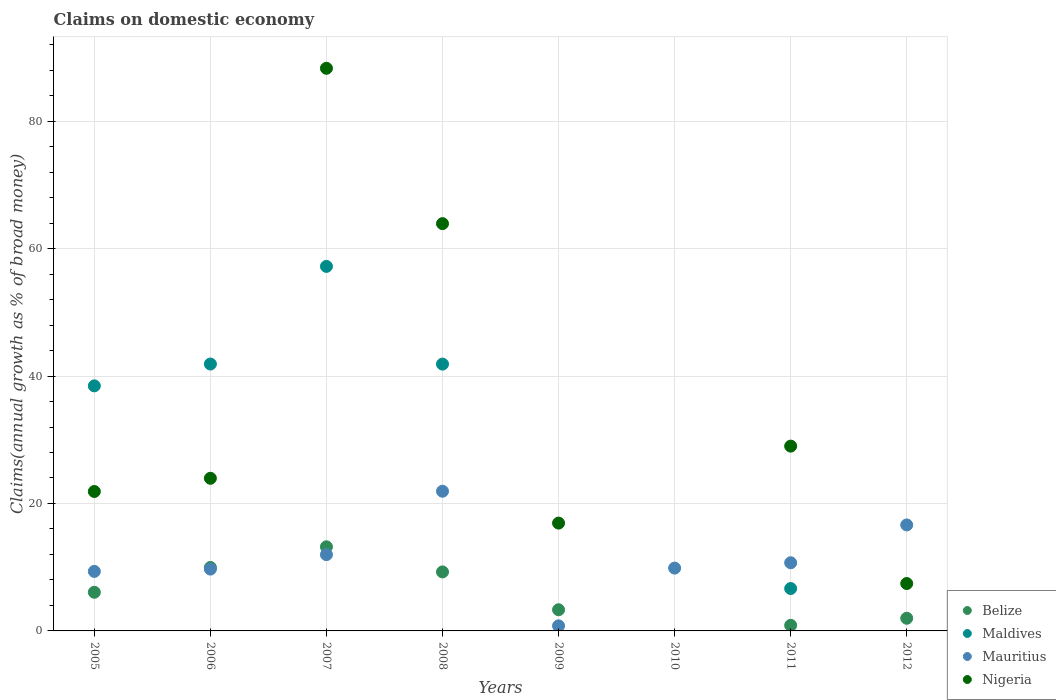How many different coloured dotlines are there?
Keep it short and to the point. 4. What is the percentage of broad money claimed on domestic economy in Nigeria in 2008?
Your answer should be compact. 63.92. Across all years, what is the maximum percentage of broad money claimed on domestic economy in Nigeria?
Make the answer very short. 88.3. Across all years, what is the minimum percentage of broad money claimed on domestic economy in Maldives?
Offer a terse response. 0. In which year was the percentage of broad money claimed on domestic economy in Mauritius maximum?
Provide a short and direct response. 2008. What is the total percentage of broad money claimed on domestic economy in Mauritius in the graph?
Ensure brevity in your answer.  90.93. What is the difference between the percentage of broad money claimed on domestic economy in Mauritius in 2005 and that in 2012?
Your answer should be very brief. -7.29. What is the difference between the percentage of broad money claimed on domestic economy in Nigeria in 2006 and the percentage of broad money claimed on domestic economy in Belize in 2005?
Provide a succinct answer. 17.89. What is the average percentage of broad money claimed on domestic economy in Belize per year?
Offer a very short reply. 5.58. In the year 2006, what is the difference between the percentage of broad money claimed on domestic economy in Mauritius and percentage of broad money claimed on domestic economy in Belize?
Give a very brief answer. -0.25. In how many years, is the percentage of broad money claimed on domestic economy in Nigeria greater than 44 %?
Make the answer very short. 2. What is the ratio of the percentage of broad money claimed on domestic economy in Mauritius in 2008 to that in 2011?
Provide a succinct answer. 2.05. Is the percentage of broad money claimed on domestic economy in Mauritius in 2009 less than that in 2011?
Offer a very short reply. Yes. Is the difference between the percentage of broad money claimed on domestic economy in Mauritius in 2008 and 2012 greater than the difference between the percentage of broad money claimed on domestic economy in Belize in 2008 and 2012?
Provide a succinct answer. No. What is the difference between the highest and the second highest percentage of broad money claimed on domestic economy in Belize?
Give a very brief answer. 3.24. What is the difference between the highest and the lowest percentage of broad money claimed on domestic economy in Maldives?
Your response must be concise. 57.21. Is it the case that in every year, the sum of the percentage of broad money claimed on domestic economy in Mauritius and percentage of broad money claimed on domestic economy in Belize  is greater than the sum of percentage of broad money claimed on domestic economy in Maldives and percentage of broad money claimed on domestic economy in Nigeria?
Offer a terse response. No. Does the percentage of broad money claimed on domestic economy in Nigeria monotonically increase over the years?
Offer a terse response. No. Is the percentage of broad money claimed on domestic economy in Mauritius strictly less than the percentage of broad money claimed on domestic economy in Nigeria over the years?
Make the answer very short. No. How many dotlines are there?
Ensure brevity in your answer.  4. How many years are there in the graph?
Ensure brevity in your answer.  8. What is the difference between two consecutive major ticks on the Y-axis?
Make the answer very short. 20. Does the graph contain any zero values?
Ensure brevity in your answer.  Yes. Does the graph contain grids?
Give a very brief answer. Yes. How many legend labels are there?
Offer a very short reply. 4. How are the legend labels stacked?
Your response must be concise. Vertical. What is the title of the graph?
Provide a short and direct response. Claims on domestic economy. What is the label or title of the X-axis?
Your answer should be compact. Years. What is the label or title of the Y-axis?
Offer a very short reply. Claims(annual growth as % of broad money). What is the Claims(annual growth as % of broad money) in Belize in 2005?
Your answer should be compact. 6.07. What is the Claims(annual growth as % of broad money) of Maldives in 2005?
Your answer should be very brief. 38.46. What is the Claims(annual growth as % of broad money) of Mauritius in 2005?
Keep it short and to the point. 9.34. What is the Claims(annual growth as % of broad money) in Nigeria in 2005?
Provide a short and direct response. 21.88. What is the Claims(annual growth as % of broad money) in Belize in 2006?
Offer a terse response. 9.96. What is the Claims(annual growth as % of broad money) of Maldives in 2006?
Offer a terse response. 41.89. What is the Claims(annual growth as % of broad money) of Mauritius in 2006?
Provide a short and direct response. 9.7. What is the Claims(annual growth as % of broad money) of Nigeria in 2006?
Make the answer very short. 23.95. What is the Claims(annual growth as % of broad money) of Belize in 2007?
Your answer should be compact. 13.2. What is the Claims(annual growth as % of broad money) of Maldives in 2007?
Your answer should be compact. 57.21. What is the Claims(annual growth as % of broad money) in Mauritius in 2007?
Your response must be concise. 11.97. What is the Claims(annual growth as % of broad money) in Nigeria in 2007?
Keep it short and to the point. 88.3. What is the Claims(annual growth as % of broad money) of Belize in 2008?
Your answer should be very brief. 9.26. What is the Claims(annual growth as % of broad money) of Maldives in 2008?
Your answer should be very brief. 41.87. What is the Claims(annual growth as % of broad money) in Mauritius in 2008?
Your answer should be compact. 21.92. What is the Claims(annual growth as % of broad money) in Nigeria in 2008?
Your response must be concise. 63.92. What is the Claims(annual growth as % of broad money) of Belize in 2009?
Offer a very short reply. 3.32. What is the Claims(annual growth as % of broad money) of Maldives in 2009?
Your answer should be very brief. 0. What is the Claims(annual growth as % of broad money) of Mauritius in 2009?
Offer a very short reply. 0.8. What is the Claims(annual growth as % of broad money) in Nigeria in 2009?
Offer a terse response. 16.92. What is the Claims(annual growth as % of broad money) of Maldives in 2010?
Offer a terse response. 0. What is the Claims(annual growth as % of broad money) in Mauritius in 2010?
Offer a terse response. 9.86. What is the Claims(annual growth as % of broad money) of Belize in 2011?
Your answer should be very brief. 0.88. What is the Claims(annual growth as % of broad money) of Maldives in 2011?
Keep it short and to the point. 6.65. What is the Claims(annual growth as % of broad money) of Mauritius in 2011?
Your answer should be compact. 10.7. What is the Claims(annual growth as % of broad money) of Nigeria in 2011?
Provide a succinct answer. 29. What is the Claims(annual growth as % of broad money) of Belize in 2012?
Offer a very short reply. 1.99. What is the Claims(annual growth as % of broad money) in Maldives in 2012?
Provide a succinct answer. 0. What is the Claims(annual growth as % of broad money) of Mauritius in 2012?
Keep it short and to the point. 16.63. What is the Claims(annual growth as % of broad money) in Nigeria in 2012?
Your answer should be very brief. 7.44. Across all years, what is the maximum Claims(annual growth as % of broad money) in Belize?
Your answer should be compact. 13.2. Across all years, what is the maximum Claims(annual growth as % of broad money) in Maldives?
Make the answer very short. 57.21. Across all years, what is the maximum Claims(annual growth as % of broad money) of Mauritius?
Ensure brevity in your answer.  21.92. Across all years, what is the maximum Claims(annual growth as % of broad money) in Nigeria?
Your response must be concise. 88.3. Across all years, what is the minimum Claims(annual growth as % of broad money) of Belize?
Offer a very short reply. 0. Across all years, what is the minimum Claims(annual growth as % of broad money) in Maldives?
Give a very brief answer. 0. Across all years, what is the minimum Claims(annual growth as % of broad money) in Mauritius?
Ensure brevity in your answer.  0.8. Across all years, what is the minimum Claims(annual growth as % of broad money) in Nigeria?
Provide a short and direct response. 0. What is the total Claims(annual growth as % of broad money) of Belize in the graph?
Your response must be concise. 44.68. What is the total Claims(annual growth as % of broad money) of Maldives in the graph?
Provide a short and direct response. 186.08. What is the total Claims(annual growth as % of broad money) in Mauritius in the graph?
Your answer should be very brief. 90.93. What is the total Claims(annual growth as % of broad money) of Nigeria in the graph?
Your answer should be very brief. 251.41. What is the difference between the Claims(annual growth as % of broad money) of Belize in 2005 and that in 2006?
Provide a succinct answer. -3.89. What is the difference between the Claims(annual growth as % of broad money) in Maldives in 2005 and that in 2006?
Ensure brevity in your answer.  -3.43. What is the difference between the Claims(annual growth as % of broad money) in Mauritius in 2005 and that in 2006?
Keep it short and to the point. -0.36. What is the difference between the Claims(annual growth as % of broad money) of Nigeria in 2005 and that in 2006?
Ensure brevity in your answer.  -2.07. What is the difference between the Claims(annual growth as % of broad money) of Belize in 2005 and that in 2007?
Provide a short and direct response. -7.14. What is the difference between the Claims(annual growth as % of broad money) in Maldives in 2005 and that in 2007?
Provide a short and direct response. -18.75. What is the difference between the Claims(annual growth as % of broad money) of Mauritius in 2005 and that in 2007?
Your answer should be compact. -2.63. What is the difference between the Claims(annual growth as % of broad money) in Nigeria in 2005 and that in 2007?
Your answer should be compact. -66.42. What is the difference between the Claims(annual growth as % of broad money) of Belize in 2005 and that in 2008?
Keep it short and to the point. -3.19. What is the difference between the Claims(annual growth as % of broad money) of Maldives in 2005 and that in 2008?
Offer a very short reply. -3.41. What is the difference between the Claims(annual growth as % of broad money) of Mauritius in 2005 and that in 2008?
Offer a very short reply. -12.58. What is the difference between the Claims(annual growth as % of broad money) in Nigeria in 2005 and that in 2008?
Provide a short and direct response. -42.04. What is the difference between the Claims(annual growth as % of broad money) of Belize in 2005 and that in 2009?
Provide a short and direct response. 2.74. What is the difference between the Claims(annual growth as % of broad money) in Mauritius in 2005 and that in 2009?
Give a very brief answer. 8.54. What is the difference between the Claims(annual growth as % of broad money) of Nigeria in 2005 and that in 2009?
Your response must be concise. 4.96. What is the difference between the Claims(annual growth as % of broad money) of Mauritius in 2005 and that in 2010?
Your answer should be very brief. -0.52. What is the difference between the Claims(annual growth as % of broad money) in Belize in 2005 and that in 2011?
Offer a very short reply. 5.19. What is the difference between the Claims(annual growth as % of broad money) in Maldives in 2005 and that in 2011?
Provide a short and direct response. 31.81. What is the difference between the Claims(annual growth as % of broad money) of Mauritius in 2005 and that in 2011?
Offer a terse response. -1.36. What is the difference between the Claims(annual growth as % of broad money) of Nigeria in 2005 and that in 2011?
Your answer should be compact. -7.12. What is the difference between the Claims(annual growth as % of broad money) in Belize in 2005 and that in 2012?
Make the answer very short. 4.08. What is the difference between the Claims(annual growth as % of broad money) in Mauritius in 2005 and that in 2012?
Offer a terse response. -7.29. What is the difference between the Claims(annual growth as % of broad money) in Nigeria in 2005 and that in 2012?
Offer a terse response. 14.44. What is the difference between the Claims(annual growth as % of broad money) in Belize in 2006 and that in 2007?
Offer a terse response. -3.24. What is the difference between the Claims(annual growth as % of broad money) of Maldives in 2006 and that in 2007?
Offer a very short reply. -15.32. What is the difference between the Claims(annual growth as % of broad money) in Mauritius in 2006 and that in 2007?
Provide a succinct answer. -2.27. What is the difference between the Claims(annual growth as % of broad money) of Nigeria in 2006 and that in 2007?
Your response must be concise. -64.34. What is the difference between the Claims(annual growth as % of broad money) of Belize in 2006 and that in 2008?
Provide a succinct answer. 0.7. What is the difference between the Claims(annual growth as % of broad money) of Maldives in 2006 and that in 2008?
Make the answer very short. 0.01. What is the difference between the Claims(annual growth as % of broad money) in Mauritius in 2006 and that in 2008?
Offer a very short reply. -12.22. What is the difference between the Claims(annual growth as % of broad money) in Nigeria in 2006 and that in 2008?
Your answer should be very brief. -39.96. What is the difference between the Claims(annual growth as % of broad money) in Belize in 2006 and that in 2009?
Provide a succinct answer. 6.64. What is the difference between the Claims(annual growth as % of broad money) of Mauritius in 2006 and that in 2009?
Offer a very short reply. 8.91. What is the difference between the Claims(annual growth as % of broad money) in Nigeria in 2006 and that in 2009?
Ensure brevity in your answer.  7.03. What is the difference between the Claims(annual growth as % of broad money) in Mauritius in 2006 and that in 2010?
Provide a short and direct response. -0.16. What is the difference between the Claims(annual growth as % of broad money) of Belize in 2006 and that in 2011?
Provide a short and direct response. 9.08. What is the difference between the Claims(annual growth as % of broad money) in Maldives in 2006 and that in 2011?
Give a very brief answer. 35.23. What is the difference between the Claims(annual growth as % of broad money) in Mauritius in 2006 and that in 2011?
Your answer should be compact. -0.99. What is the difference between the Claims(annual growth as % of broad money) of Nigeria in 2006 and that in 2011?
Make the answer very short. -5.05. What is the difference between the Claims(annual growth as % of broad money) in Belize in 2006 and that in 2012?
Keep it short and to the point. 7.97. What is the difference between the Claims(annual growth as % of broad money) of Mauritius in 2006 and that in 2012?
Your answer should be compact. -6.93. What is the difference between the Claims(annual growth as % of broad money) in Nigeria in 2006 and that in 2012?
Offer a very short reply. 16.52. What is the difference between the Claims(annual growth as % of broad money) in Belize in 2007 and that in 2008?
Offer a terse response. 3.94. What is the difference between the Claims(annual growth as % of broad money) in Maldives in 2007 and that in 2008?
Offer a very short reply. 15.33. What is the difference between the Claims(annual growth as % of broad money) of Mauritius in 2007 and that in 2008?
Offer a very short reply. -9.95. What is the difference between the Claims(annual growth as % of broad money) of Nigeria in 2007 and that in 2008?
Provide a succinct answer. 24.38. What is the difference between the Claims(annual growth as % of broad money) of Belize in 2007 and that in 2009?
Your answer should be compact. 9.88. What is the difference between the Claims(annual growth as % of broad money) in Mauritius in 2007 and that in 2009?
Keep it short and to the point. 11.17. What is the difference between the Claims(annual growth as % of broad money) in Nigeria in 2007 and that in 2009?
Keep it short and to the point. 71.38. What is the difference between the Claims(annual growth as % of broad money) in Mauritius in 2007 and that in 2010?
Your answer should be compact. 2.11. What is the difference between the Claims(annual growth as % of broad money) in Belize in 2007 and that in 2011?
Provide a succinct answer. 12.32. What is the difference between the Claims(annual growth as % of broad money) in Maldives in 2007 and that in 2011?
Provide a short and direct response. 50.55. What is the difference between the Claims(annual growth as % of broad money) of Mauritius in 2007 and that in 2011?
Ensure brevity in your answer.  1.27. What is the difference between the Claims(annual growth as % of broad money) of Nigeria in 2007 and that in 2011?
Offer a terse response. 59.3. What is the difference between the Claims(annual growth as % of broad money) of Belize in 2007 and that in 2012?
Ensure brevity in your answer.  11.21. What is the difference between the Claims(annual growth as % of broad money) of Mauritius in 2007 and that in 2012?
Make the answer very short. -4.66. What is the difference between the Claims(annual growth as % of broad money) in Nigeria in 2007 and that in 2012?
Make the answer very short. 80.86. What is the difference between the Claims(annual growth as % of broad money) of Belize in 2008 and that in 2009?
Give a very brief answer. 5.94. What is the difference between the Claims(annual growth as % of broad money) of Mauritius in 2008 and that in 2009?
Your response must be concise. 21.12. What is the difference between the Claims(annual growth as % of broad money) of Nigeria in 2008 and that in 2009?
Give a very brief answer. 47. What is the difference between the Claims(annual growth as % of broad money) of Mauritius in 2008 and that in 2010?
Offer a very short reply. 12.06. What is the difference between the Claims(annual growth as % of broad money) of Belize in 2008 and that in 2011?
Make the answer very short. 8.38. What is the difference between the Claims(annual growth as % of broad money) of Maldives in 2008 and that in 2011?
Offer a terse response. 35.22. What is the difference between the Claims(annual growth as % of broad money) in Mauritius in 2008 and that in 2011?
Your answer should be very brief. 11.23. What is the difference between the Claims(annual growth as % of broad money) in Nigeria in 2008 and that in 2011?
Ensure brevity in your answer.  34.92. What is the difference between the Claims(annual growth as % of broad money) of Belize in 2008 and that in 2012?
Offer a terse response. 7.27. What is the difference between the Claims(annual growth as % of broad money) of Mauritius in 2008 and that in 2012?
Offer a terse response. 5.29. What is the difference between the Claims(annual growth as % of broad money) of Nigeria in 2008 and that in 2012?
Offer a terse response. 56.48. What is the difference between the Claims(annual growth as % of broad money) of Mauritius in 2009 and that in 2010?
Make the answer very short. -9.06. What is the difference between the Claims(annual growth as % of broad money) of Belize in 2009 and that in 2011?
Offer a very short reply. 2.44. What is the difference between the Claims(annual growth as % of broad money) in Mauritius in 2009 and that in 2011?
Your answer should be compact. -9.9. What is the difference between the Claims(annual growth as % of broad money) in Nigeria in 2009 and that in 2011?
Keep it short and to the point. -12.08. What is the difference between the Claims(annual growth as % of broad money) of Belize in 2009 and that in 2012?
Give a very brief answer. 1.33. What is the difference between the Claims(annual growth as % of broad money) of Mauritius in 2009 and that in 2012?
Your answer should be compact. -15.83. What is the difference between the Claims(annual growth as % of broad money) in Nigeria in 2009 and that in 2012?
Ensure brevity in your answer.  9.48. What is the difference between the Claims(annual growth as % of broad money) in Mauritius in 2010 and that in 2011?
Ensure brevity in your answer.  -0.84. What is the difference between the Claims(annual growth as % of broad money) in Mauritius in 2010 and that in 2012?
Provide a short and direct response. -6.77. What is the difference between the Claims(annual growth as % of broad money) in Belize in 2011 and that in 2012?
Your response must be concise. -1.11. What is the difference between the Claims(annual growth as % of broad money) of Mauritius in 2011 and that in 2012?
Ensure brevity in your answer.  -5.93. What is the difference between the Claims(annual growth as % of broad money) of Nigeria in 2011 and that in 2012?
Make the answer very short. 21.57. What is the difference between the Claims(annual growth as % of broad money) in Belize in 2005 and the Claims(annual growth as % of broad money) in Maldives in 2006?
Offer a very short reply. -35.82. What is the difference between the Claims(annual growth as % of broad money) in Belize in 2005 and the Claims(annual growth as % of broad money) in Mauritius in 2006?
Keep it short and to the point. -3.64. What is the difference between the Claims(annual growth as % of broad money) of Belize in 2005 and the Claims(annual growth as % of broad money) of Nigeria in 2006?
Offer a terse response. -17.89. What is the difference between the Claims(annual growth as % of broad money) in Maldives in 2005 and the Claims(annual growth as % of broad money) in Mauritius in 2006?
Give a very brief answer. 28.76. What is the difference between the Claims(annual growth as % of broad money) in Maldives in 2005 and the Claims(annual growth as % of broad money) in Nigeria in 2006?
Ensure brevity in your answer.  14.51. What is the difference between the Claims(annual growth as % of broad money) of Mauritius in 2005 and the Claims(annual growth as % of broad money) of Nigeria in 2006?
Give a very brief answer. -14.61. What is the difference between the Claims(annual growth as % of broad money) in Belize in 2005 and the Claims(annual growth as % of broad money) in Maldives in 2007?
Offer a terse response. -51.14. What is the difference between the Claims(annual growth as % of broad money) in Belize in 2005 and the Claims(annual growth as % of broad money) in Mauritius in 2007?
Ensure brevity in your answer.  -5.9. What is the difference between the Claims(annual growth as % of broad money) in Belize in 2005 and the Claims(annual growth as % of broad money) in Nigeria in 2007?
Your response must be concise. -82.23. What is the difference between the Claims(annual growth as % of broad money) in Maldives in 2005 and the Claims(annual growth as % of broad money) in Mauritius in 2007?
Provide a succinct answer. 26.49. What is the difference between the Claims(annual growth as % of broad money) in Maldives in 2005 and the Claims(annual growth as % of broad money) in Nigeria in 2007?
Keep it short and to the point. -49.84. What is the difference between the Claims(annual growth as % of broad money) in Mauritius in 2005 and the Claims(annual growth as % of broad money) in Nigeria in 2007?
Offer a very short reply. -78.96. What is the difference between the Claims(annual growth as % of broad money) of Belize in 2005 and the Claims(annual growth as % of broad money) of Maldives in 2008?
Offer a terse response. -35.81. What is the difference between the Claims(annual growth as % of broad money) of Belize in 2005 and the Claims(annual growth as % of broad money) of Mauritius in 2008?
Give a very brief answer. -15.86. What is the difference between the Claims(annual growth as % of broad money) of Belize in 2005 and the Claims(annual growth as % of broad money) of Nigeria in 2008?
Provide a short and direct response. -57.85. What is the difference between the Claims(annual growth as % of broad money) of Maldives in 2005 and the Claims(annual growth as % of broad money) of Mauritius in 2008?
Keep it short and to the point. 16.54. What is the difference between the Claims(annual growth as % of broad money) of Maldives in 2005 and the Claims(annual growth as % of broad money) of Nigeria in 2008?
Offer a terse response. -25.46. What is the difference between the Claims(annual growth as % of broad money) in Mauritius in 2005 and the Claims(annual growth as % of broad money) in Nigeria in 2008?
Make the answer very short. -54.58. What is the difference between the Claims(annual growth as % of broad money) of Belize in 2005 and the Claims(annual growth as % of broad money) of Mauritius in 2009?
Make the answer very short. 5.27. What is the difference between the Claims(annual growth as % of broad money) in Belize in 2005 and the Claims(annual growth as % of broad money) in Nigeria in 2009?
Provide a succinct answer. -10.85. What is the difference between the Claims(annual growth as % of broad money) in Maldives in 2005 and the Claims(annual growth as % of broad money) in Mauritius in 2009?
Provide a succinct answer. 37.66. What is the difference between the Claims(annual growth as % of broad money) of Maldives in 2005 and the Claims(annual growth as % of broad money) of Nigeria in 2009?
Offer a very short reply. 21.54. What is the difference between the Claims(annual growth as % of broad money) in Mauritius in 2005 and the Claims(annual growth as % of broad money) in Nigeria in 2009?
Provide a short and direct response. -7.58. What is the difference between the Claims(annual growth as % of broad money) in Belize in 2005 and the Claims(annual growth as % of broad money) in Mauritius in 2010?
Ensure brevity in your answer.  -3.79. What is the difference between the Claims(annual growth as % of broad money) in Maldives in 2005 and the Claims(annual growth as % of broad money) in Mauritius in 2010?
Ensure brevity in your answer.  28.6. What is the difference between the Claims(annual growth as % of broad money) in Belize in 2005 and the Claims(annual growth as % of broad money) in Maldives in 2011?
Your response must be concise. -0.59. What is the difference between the Claims(annual growth as % of broad money) of Belize in 2005 and the Claims(annual growth as % of broad money) of Mauritius in 2011?
Offer a very short reply. -4.63. What is the difference between the Claims(annual growth as % of broad money) in Belize in 2005 and the Claims(annual growth as % of broad money) in Nigeria in 2011?
Make the answer very short. -22.94. What is the difference between the Claims(annual growth as % of broad money) of Maldives in 2005 and the Claims(annual growth as % of broad money) of Mauritius in 2011?
Your answer should be compact. 27.76. What is the difference between the Claims(annual growth as % of broad money) of Maldives in 2005 and the Claims(annual growth as % of broad money) of Nigeria in 2011?
Your answer should be compact. 9.46. What is the difference between the Claims(annual growth as % of broad money) in Mauritius in 2005 and the Claims(annual growth as % of broad money) in Nigeria in 2011?
Provide a succinct answer. -19.66. What is the difference between the Claims(annual growth as % of broad money) of Belize in 2005 and the Claims(annual growth as % of broad money) of Mauritius in 2012?
Your answer should be compact. -10.57. What is the difference between the Claims(annual growth as % of broad money) of Belize in 2005 and the Claims(annual growth as % of broad money) of Nigeria in 2012?
Offer a terse response. -1.37. What is the difference between the Claims(annual growth as % of broad money) of Maldives in 2005 and the Claims(annual growth as % of broad money) of Mauritius in 2012?
Your answer should be very brief. 21.83. What is the difference between the Claims(annual growth as % of broad money) of Maldives in 2005 and the Claims(annual growth as % of broad money) of Nigeria in 2012?
Your response must be concise. 31.02. What is the difference between the Claims(annual growth as % of broad money) of Mauritius in 2005 and the Claims(annual growth as % of broad money) of Nigeria in 2012?
Give a very brief answer. 1.9. What is the difference between the Claims(annual growth as % of broad money) in Belize in 2006 and the Claims(annual growth as % of broad money) in Maldives in 2007?
Offer a terse response. -47.25. What is the difference between the Claims(annual growth as % of broad money) of Belize in 2006 and the Claims(annual growth as % of broad money) of Mauritius in 2007?
Offer a very short reply. -2.01. What is the difference between the Claims(annual growth as % of broad money) of Belize in 2006 and the Claims(annual growth as % of broad money) of Nigeria in 2007?
Offer a very short reply. -78.34. What is the difference between the Claims(annual growth as % of broad money) of Maldives in 2006 and the Claims(annual growth as % of broad money) of Mauritius in 2007?
Offer a terse response. 29.92. What is the difference between the Claims(annual growth as % of broad money) of Maldives in 2006 and the Claims(annual growth as % of broad money) of Nigeria in 2007?
Give a very brief answer. -46.41. What is the difference between the Claims(annual growth as % of broad money) of Mauritius in 2006 and the Claims(annual growth as % of broad money) of Nigeria in 2007?
Your response must be concise. -78.59. What is the difference between the Claims(annual growth as % of broad money) of Belize in 2006 and the Claims(annual growth as % of broad money) of Maldives in 2008?
Provide a succinct answer. -31.91. What is the difference between the Claims(annual growth as % of broad money) in Belize in 2006 and the Claims(annual growth as % of broad money) in Mauritius in 2008?
Your answer should be compact. -11.96. What is the difference between the Claims(annual growth as % of broad money) in Belize in 2006 and the Claims(annual growth as % of broad money) in Nigeria in 2008?
Your response must be concise. -53.96. What is the difference between the Claims(annual growth as % of broad money) of Maldives in 2006 and the Claims(annual growth as % of broad money) of Mauritius in 2008?
Give a very brief answer. 19.96. What is the difference between the Claims(annual growth as % of broad money) in Maldives in 2006 and the Claims(annual growth as % of broad money) in Nigeria in 2008?
Your answer should be compact. -22.03. What is the difference between the Claims(annual growth as % of broad money) in Mauritius in 2006 and the Claims(annual growth as % of broad money) in Nigeria in 2008?
Ensure brevity in your answer.  -54.21. What is the difference between the Claims(annual growth as % of broad money) of Belize in 2006 and the Claims(annual growth as % of broad money) of Mauritius in 2009?
Your answer should be compact. 9.16. What is the difference between the Claims(annual growth as % of broad money) of Belize in 2006 and the Claims(annual growth as % of broad money) of Nigeria in 2009?
Your response must be concise. -6.96. What is the difference between the Claims(annual growth as % of broad money) of Maldives in 2006 and the Claims(annual growth as % of broad money) of Mauritius in 2009?
Offer a terse response. 41.09. What is the difference between the Claims(annual growth as % of broad money) in Maldives in 2006 and the Claims(annual growth as % of broad money) in Nigeria in 2009?
Provide a succinct answer. 24.97. What is the difference between the Claims(annual growth as % of broad money) in Mauritius in 2006 and the Claims(annual growth as % of broad money) in Nigeria in 2009?
Offer a terse response. -7.22. What is the difference between the Claims(annual growth as % of broad money) of Belize in 2006 and the Claims(annual growth as % of broad money) of Mauritius in 2010?
Your answer should be compact. 0.1. What is the difference between the Claims(annual growth as % of broad money) of Maldives in 2006 and the Claims(annual growth as % of broad money) of Mauritius in 2010?
Provide a succinct answer. 32.03. What is the difference between the Claims(annual growth as % of broad money) of Belize in 2006 and the Claims(annual growth as % of broad money) of Maldives in 2011?
Ensure brevity in your answer.  3.3. What is the difference between the Claims(annual growth as % of broad money) in Belize in 2006 and the Claims(annual growth as % of broad money) in Mauritius in 2011?
Give a very brief answer. -0.74. What is the difference between the Claims(annual growth as % of broad money) in Belize in 2006 and the Claims(annual growth as % of broad money) in Nigeria in 2011?
Ensure brevity in your answer.  -19.04. What is the difference between the Claims(annual growth as % of broad money) in Maldives in 2006 and the Claims(annual growth as % of broad money) in Mauritius in 2011?
Give a very brief answer. 31.19. What is the difference between the Claims(annual growth as % of broad money) of Maldives in 2006 and the Claims(annual growth as % of broad money) of Nigeria in 2011?
Make the answer very short. 12.88. What is the difference between the Claims(annual growth as % of broad money) of Mauritius in 2006 and the Claims(annual growth as % of broad money) of Nigeria in 2011?
Give a very brief answer. -19.3. What is the difference between the Claims(annual growth as % of broad money) in Belize in 2006 and the Claims(annual growth as % of broad money) in Mauritius in 2012?
Give a very brief answer. -6.67. What is the difference between the Claims(annual growth as % of broad money) of Belize in 2006 and the Claims(annual growth as % of broad money) of Nigeria in 2012?
Your answer should be compact. 2.52. What is the difference between the Claims(annual growth as % of broad money) of Maldives in 2006 and the Claims(annual growth as % of broad money) of Mauritius in 2012?
Provide a succinct answer. 25.25. What is the difference between the Claims(annual growth as % of broad money) of Maldives in 2006 and the Claims(annual growth as % of broad money) of Nigeria in 2012?
Make the answer very short. 34.45. What is the difference between the Claims(annual growth as % of broad money) of Mauritius in 2006 and the Claims(annual growth as % of broad money) of Nigeria in 2012?
Provide a short and direct response. 2.27. What is the difference between the Claims(annual growth as % of broad money) of Belize in 2007 and the Claims(annual growth as % of broad money) of Maldives in 2008?
Ensure brevity in your answer.  -28.67. What is the difference between the Claims(annual growth as % of broad money) in Belize in 2007 and the Claims(annual growth as % of broad money) in Mauritius in 2008?
Your response must be concise. -8.72. What is the difference between the Claims(annual growth as % of broad money) of Belize in 2007 and the Claims(annual growth as % of broad money) of Nigeria in 2008?
Your response must be concise. -50.72. What is the difference between the Claims(annual growth as % of broad money) in Maldives in 2007 and the Claims(annual growth as % of broad money) in Mauritius in 2008?
Your answer should be very brief. 35.28. What is the difference between the Claims(annual growth as % of broad money) in Maldives in 2007 and the Claims(annual growth as % of broad money) in Nigeria in 2008?
Provide a short and direct response. -6.71. What is the difference between the Claims(annual growth as % of broad money) in Mauritius in 2007 and the Claims(annual growth as % of broad money) in Nigeria in 2008?
Ensure brevity in your answer.  -51.95. What is the difference between the Claims(annual growth as % of broad money) in Belize in 2007 and the Claims(annual growth as % of broad money) in Mauritius in 2009?
Your answer should be very brief. 12.4. What is the difference between the Claims(annual growth as % of broad money) in Belize in 2007 and the Claims(annual growth as % of broad money) in Nigeria in 2009?
Provide a short and direct response. -3.72. What is the difference between the Claims(annual growth as % of broad money) of Maldives in 2007 and the Claims(annual growth as % of broad money) of Mauritius in 2009?
Provide a succinct answer. 56.41. What is the difference between the Claims(annual growth as % of broad money) in Maldives in 2007 and the Claims(annual growth as % of broad money) in Nigeria in 2009?
Provide a short and direct response. 40.28. What is the difference between the Claims(annual growth as % of broad money) of Mauritius in 2007 and the Claims(annual growth as % of broad money) of Nigeria in 2009?
Offer a terse response. -4.95. What is the difference between the Claims(annual growth as % of broad money) of Belize in 2007 and the Claims(annual growth as % of broad money) of Mauritius in 2010?
Make the answer very short. 3.34. What is the difference between the Claims(annual growth as % of broad money) of Maldives in 2007 and the Claims(annual growth as % of broad money) of Mauritius in 2010?
Your answer should be very brief. 47.35. What is the difference between the Claims(annual growth as % of broad money) in Belize in 2007 and the Claims(annual growth as % of broad money) in Maldives in 2011?
Your response must be concise. 6.55. What is the difference between the Claims(annual growth as % of broad money) in Belize in 2007 and the Claims(annual growth as % of broad money) in Mauritius in 2011?
Make the answer very short. 2.5. What is the difference between the Claims(annual growth as % of broad money) of Belize in 2007 and the Claims(annual growth as % of broad money) of Nigeria in 2011?
Ensure brevity in your answer.  -15.8. What is the difference between the Claims(annual growth as % of broad money) of Maldives in 2007 and the Claims(annual growth as % of broad money) of Mauritius in 2011?
Ensure brevity in your answer.  46.51. What is the difference between the Claims(annual growth as % of broad money) in Maldives in 2007 and the Claims(annual growth as % of broad money) in Nigeria in 2011?
Provide a succinct answer. 28.2. What is the difference between the Claims(annual growth as % of broad money) of Mauritius in 2007 and the Claims(annual growth as % of broad money) of Nigeria in 2011?
Offer a terse response. -17.03. What is the difference between the Claims(annual growth as % of broad money) in Belize in 2007 and the Claims(annual growth as % of broad money) in Mauritius in 2012?
Offer a very short reply. -3.43. What is the difference between the Claims(annual growth as % of broad money) in Belize in 2007 and the Claims(annual growth as % of broad money) in Nigeria in 2012?
Give a very brief answer. 5.76. What is the difference between the Claims(annual growth as % of broad money) in Maldives in 2007 and the Claims(annual growth as % of broad money) in Mauritius in 2012?
Make the answer very short. 40.57. What is the difference between the Claims(annual growth as % of broad money) of Maldives in 2007 and the Claims(annual growth as % of broad money) of Nigeria in 2012?
Provide a succinct answer. 49.77. What is the difference between the Claims(annual growth as % of broad money) in Mauritius in 2007 and the Claims(annual growth as % of broad money) in Nigeria in 2012?
Provide a short and direct response. 4.53. What is the difference between the Claims(annual growth as % of broad money) in Belize in 2008 and the Claims(annual growth as % of broad money) in Mauritius in 2009?
Your answer should be very brief. 8.46. What is the difference between the Claims(annual growth as % of broad money) in Belize in 2008 and the Claims(annual growth as % of broad money) in Nigeria in 2009?
Ensure brevity in your answer.  -7.66. What is the difference between the Claims(annual growth as % of broad money) of Maldives in 2008 and the Claims(annual growth as % of broad money) of Mauritius in 2009?
Make the answer very short. 41.08. What is the difference between the Claims(annual growth as % of broad money) of Maldives in 2008 and the Claims(annual growth as % of broad money) of Nigeria in 2009?
Offer a terse response. 24.95. What is the difference between the Claims(annual growth as % of broad money) in Mauritius in 2008 and the Claims(annual growth as % of broad money) in Nigeria in 2009?
Give a very brief answer. 5. What is the difference between the Claims(annual growth as % of broad money) of Belize in 2008 and the Claims(annual growth as % of broad money) of Mauritius in 2010?
Your answer should be very brief. -0.6. What is the difference between the Claims(annual growth as % of broad money) of Maldives in 2008 and the Claims(annual growth as % of broad money) of Mauritius in 2010?
Your answer should be very brief. 32.01. What is the difference between the Claims(annual growth as % of broad money) of Belize in 2008 and the Claims(annual growth as % of broad money) of Maldives in 2011?
Provide a short and direct response. 2.61. What is the difference between the Claims(annual growth as % of broad money) in Belize in 2008 and the Claims(annual growth as % of broad money) in Mauritius in 2011?
Offer a very short reply. -1.44. What is the difference between the Claims(annual growth as % of broad money) of Belize in 2008 and the Claims(annual growth as % of broad money) of Nigeria in 2011?
Your answer should be very brief. -19.74. What is the difference between the Claims(annual growth as % of broad money) in Maldives in 2008 and the Claims(annual growth as % of broad money) in Mauritius in 2011?
Your response must be concise. 31.18. What is the difference between the Claims(annual growth as % of broad money) in Maldives in 2008 and the Claims(annual growth as % of broad money) in Nigeria in 2011?
Provide a short and direct response. 12.87. What is the difference between the Claims(annual growth as % of broad money) in Mauritius in 2008 and the Claims(annual growth as % of broad money) in Nigeria in 2011?
Provide a succinct answer. -7.08. What is the difference between the Claims(annual growth as % of broad money) in Belize in 2008 and the Claims(annual growth as % of broad money) in Mauritius in 2012?
Your response must be concise. -7.37. What is the difference between the Claims(annual growth as % of broad money) of Belize in 2008 and the Claims(annual growth as % of broad money) of Nigeria in 2012?
Give a very brief answer. 1.82. What is the difference between the Claims(annual growth as % of broad money) in Maldives in 2008 and the Claims(annual growth as % of broad money) in Mauritius in 2012?
Make the answer very short. 25.24. What is the difference between the Claims(annual growth as % of broad money) in Maldives in 2008 and the Claims(annual growth as % of broad money) in Nigeria in 2012?
Make the answer very short. 34.44. What is the difference between the Claims(annual growth as % of broad money) of Mauritius in 2008 and the Claims(annual growth as % of broad money) of Nigeria in 2012?
Offer a very short reply. 14.49. What is the difference between the Claims(annual growth as % of broad money) in Belize in 2009 and the Claims(annual growth as % of broad money) in Mauritius in 2010?
Provide a short and direct response. -6.54. What is the difference between the Claims(annual growth as % of broad money) of Belize in 2009 and the Claims(annual growth as % of broad money) of Maldives in 2011?
Provide a succinct answer. -3.33. What is the difference between the Claims(annual growth as % of broad money) of Belize in 2009 and the Claims(annual growth as % of broad money) of Mauritius in 2011?
Ensure brevity in your answer.  -7.38. What is the difference between the Claims(annual growth as % of broad money) of Belize in 2009 and the Claims(annual growth as % of broad money) of Nigeria in 2011?
Provide a short and direct response. -25.68. What is the difference between the Claims(annual growth as % of broad money) of Mauritius in 2009 and the Claims(annual growth as % of broad money) of Nigeria in 2011?
Make the answer very short. -28.2. What is the difference between the Claims(annual growth as % of broad money) in Belize in 2009 and the Claims(annual growth as % of broad money) in Mauritius in 2012?
Ensure brevity in your answer.  -13.31. What is the difference between the Claims(annual growth as % of broad money) in Belize in 2009 and the Claims(annual growth as % of broad money) in Nigeria in 2012?
Your answer should be compact. -4.12. What is the difference between the Claims(annual growth as % of broad money) of Mauritius in 2009 and the Claims(annual growth as % of broad money) of Nigeria in 2012?
Offer a very short reply. -6.64. What is the difference between the Claims(annual growth as % of broad money) of Mauritius in 2010 and the Claims(annual growth as % of broad money) of Nigeria in 2011?
Your answer should be very brief. -19.14. What is the difference between the Claims(annual growth as % of broad money) in Mauritius in 2010 and the Claims(annual growth as % of broad money) in Nigeria in 2012?
Keep it short and to the point. 2.42. What is the difference between the Claims(annual growth as % of broad money) in Belize in 2011 and the Claims(annual growth as % of broad money) in Mauritius in 2012?
Give a very brief answer. -15.75. What is the difference between the Claims(annual growth as % of broad money) of Belize in 2011 and the Claims(annual growth as % of broad money) of Nigeria in 2012?
Make the answer very short. -6.56. What is the difference between the Claims(annual growth as % of broad money) in Maldives in 2011 and the Claims(annual growth as % of broad money) in Mauritius in 2012?
Your answer should be compact. -9.98. What is the difference between the Claims(annual growth as % of broad money) of Maldives in 2011 and the Claims(annual growth as % of broad money) of Nigeria in 2012?
Your answer should be very brief. -0.78. What is the difference between the Claims(annual growth as % of broad money) of Mauritius in 2011 and the Claims(annual growth as % of broad money) of Nigeria in 2012?
Give a very brief answer. 3.26. What is the average Claims(annual growth as % of broad money) in Belize per year?
Offer a very short reply. 5.58. What is the average Claims(annual growth as % of broad money) in Maldives per year?
Give a very brief answer. 23.26. What is the average Claims(annual growth as % of broad money) in Mauritius per year?
Ensure brevity in your answer.  11.37. What is the average Claims(annual growth as % of broad money) of Nigeria per year?
Your answer should be compact. 31.43. In the year 2005, what is the difference between the Claims(annual growth as % of broad money) of Belize and Claims(annual growth as % of broad money) of Maldives?
Provide a short and direct response. -32.39. In the year 2005, what is the difference between the Claims(annual growth as % of broad money) in Belize and Claims(annual growth as % of broad money) in Mauritius?
Keep it short and to the point. -3.27. In the year 2005, what is the difference between the Claims(annual growth as % of broad money) of Belize and Claims(annual growth as % of broad money) of Nigeria?
Provide a short and direct response. -15.81. In the year 2005, what is the difference between the Claims(annual growth as % of broad money) of Maldives and Claims(annual growth as % of broad money) of Mauritius?
Provide a short and direct response. 29.12. In the year 2005, what is the difference between the Claims(annual growth as % of broad money) of Maldives and Claims(annual growth as % of broad money) of Nigeria?
Give a very brief answer. 16.58. In the year 2005, what is the difference between the Claims(annual growth as % of broad money) of Mauritius and Claims(annual growth as % of broad money) of Nigeria?
Offer a very short reply. -12.54. In the year 2006, what is the difference between the Claims(annual growth as % of broad money) in Belize and Claims(annual growth as % of broad money) in Maldives?
Your response must be concise. -31.93. In the year 2006, what is the difference between the Claims(annual growth as % of broad money) of Belize and Claims(annual growth as % of broad money) of Mauritius?
Ensure brevity in your answer.  0.25. In the year 2006, what is the difference between the Claims(annual growth as % of broad money) in Belize and Claims(annual growth as % of broad money) in Nigeria?
Provide a succinct answer. -14. In the year 2006, what is the difference between the Claims(annual growth as % of broad money) in Maldives and Claims(annual growth as % of broad money) in Mauritius?
Your answer should be very brief. 32.18. In the year 2006, what is the difference between the Claims(annual growth as % of broad money) of Maldives and Claims(annual growth as % of broad money) of Nigeria?
Your response must be concise. 17.93. In the year 2006, what is the difference between the Claims(annual growth as % of broad money) of Mauritius and Claims(annual growth as % of broad money) of Nigeria?
Your response must be concise. -14.25. In the year 2007, what is the difference between the Claims(annual growth as % of broad money) in Belize and Claims(annual growth as % of broad money) in Maldives?
Your response must be concise. -44. In the year 2007, what is the difference between the Claims(annual growth as % of broad money) in Belize and Claims(annual growth as % of broad money) in Mauritius?
Offer a very short reply. 1.23. In the year 2007, what is the difference between the Claims(annual growth as % of broad money) of Belize and Claims(annual growth as % of broad money) of Nigeria?
Give a very brief answer. -75.1. In the year 2007, what is the difference between the Claims(annual growth as % of broad money) in Maldives and Claims(annual growth as % of broad money) in Mauritius?
Offer a terse response. 45.24. In the year 2007, what is the difference between the Claims(annual growth as % of broad money) of Maldives and Claims(annual growth as % of broad money) of Nigeria?
Your answer should be very brief. -31.09. In the year 2007, what is the difference between the Claims(annual growth as % of broad money) of Mauritius and Claims(annual growth as % of broad money) of Nigeria?
Offer a very short reply. -76.33. In the year 2008, what is the difference between the Claims(annual growth as % of broad money) of Belize and Claims(annual growth as % of broad money) of Maldives?
Your response must be concise. -32.61. In the year 2008, what is the difference between the Claims(annual growth as % of broad money) of Belize and Claims(annual growth as % of broad money) of Mauritius?
Your answer should be very brief. -12.66. In the year 2008, what is the difference between the Claims(annual growth as % of broad money) in Belize and Claims(annual growth as % of broad money) in Nigeria?
Provide a succinct answer. -54.66. In the year 2008, what is the difference between the Claims(annual growth as % of broad money) in Maldives and Claims(annual growth as % of broad money) in Mauritius?
Offer a terse response. 19.95. In the year 2008, what is the difference between the Claims(annual growth as % of broad money) in Maldives and Claims(annual growth as % of broad money) in Nigeria?
Ensure brevity in your answer.  -22.04. In the year 2008, what is the difference between the Claims(annual growth as % of broad money) in Mauritius and Claims(annual growth as % of broad money) in Nigeria?
Make the answer very short. -41.99. In the year 2009, what is the difference between the Claims(annual growth as % of broad money) in Belize and Claims(annual growth as % of broad money) in Mauritius?
Give a very brief answer. 2.52. In the year 2009, what is the difference between the Claims(annual growth as % of broad money) in Belize and Claims(annual growth as % of broad money) in Nigeria?
Give a very brief answer. -13.6. In the year 2009, what is the difference between the Claims(annual growth as % of broad money) in Mauritius and Claims(annual growth as % of broad money) in Nigeria?
Provide a succinct answer. -16.12. In the year 2011, what is the difference between the Claims(annual growth as % of broad money) of Belize and Claims(annual growth as % of broad money) of Maldives?
Your response must be concise. -5.78. In the year 2011, what is the difference between the Claims(annual growth as % of broad money) of Belize and Claims(annual growth as % of broad money) of Mauritius?
Ensure brevity in your answer.  -9.82. In the year 2011, what is the difference between the Claims(annual growth as % of broad money) in Belize and Claims(annual growth as % of broad money) in Nigeria?
Keep it short and to the point. -28.12. In the year 2011, what is the difference between the Claims(annual growth as % of broad money) in Maldives and Claims(annual growth as % of broad money) in Mauritius?
Provide a short and direct response. -4.04. In the year 2011, what is the difference between the Claims(annual growth as % of broad money) of Maldives and Claims(annual growth as % of broad money) of Nigeria?
Give a very brief answer. -22.35. In the year 2011, what is the difference between the Claims(annual growth as % of broad money) of Mauritius and Claims(annual growth as % of broad money) of Nigeria?
Your response must be concise. -18.3. In the year 2012, what is the difference between the Claims(annual growth as % of broad money) of Belize and Claims(annual growth as % of broad money) of Mauritius?
Ensure brevity in your answer.  -14.64. In the year 2012, what is the difference between the Claims(annual growth as % of broad money) in Belize and Claims(annual growth as % of broad money) in Nigeria?
Your answer should be very brief. -5.45. In the year 2012, what is the difference between the Claims(annual growth as % of broad money) of Mauritius and Claims(annual growth as % of broad money) of Nigeria?
Provide a short and direct response. 9.19. What is the ratio of the Claims(annual growth as % of broad money) in Belize in 2005 to that in 2006?
Your answer should be very brief. 0.61. What is the ratio of the Claims(annual growth as % of broad money) in Maldives in 2005 to that in 2006?
Provide a short and direct response. 0.92. What is the ratio of the Claims(annual growth as % of broad money) of Mauritius in 2005 to that in 2006?
Keep it short and to the point. 0.96. What is the ratio of the Claims(annual growth as % of broad money) in Nigeria in 2005 to that in 2006?
Ensure brevity in your answer.  0.91. What is the ratio of the Claims(annual growth as % of broad money) of Belize in 2005 to that in 2007?
Your answer should be very brief. 0.46. What is the ratio of the Claims(annual growth as % of broad money) in Maldives in 2005 to that in 2007?
Your answer should be compact. 0.67. What is the ratio of the Claims(annual growth as % of broad money) in Mauritius in 2005 to that in 2007?
Your answer should be compact. 0.78. What is the ratio of the Claims(annual growth as % of broad money) in Nigeria in 2005 to that in 2007?
Ensure brevity in your answer.  0.25. What is the ratio of the Claims(annual growth as % of broad money) in Belize in 2005 to that in 2008?
Keep it short and to the point. 0.66. What is the ratio of the Claims(annual growth as % of broad money) of Maldives in 2005 to that in 2008?
Provide a succinct answer. 0.92. What is the ratio of the Claims(annual growth as % of broad money) of Mauritius in 2005 to that in 2008?
Offer a terse response. 0.43. What is the ratio of the Claims(annual growth as % of broad money) of Nigeria in 2005 to that in 2008?
Make the answer very short. 0.34. What is the ratio of the Claims(annual growth as % of broad money) in Belize in 2005 to that in 2009?
Ensure brevity in your answer.  1.83. What is the ratio of the Claims(annual growth as % of broad money) of Mauritius in 2005 to that in 2009?
Keep it short and to the point. 11.7. What is the ratio of the Claims(annual growth as % of broad money) of Nigeria in 2005 to that in 2009?
Make the answer very short. 1.29. What is the ratio of the Claims(annual growth as % of broad money) of Mauritius in 2005 to that in 2010?
Offer a very short reply. 0.95. What is the ratio of the Claims(annual growth as % of broad money) of Belize in 2005 to that in 2011?
Your answer should be compact. 6.91. What is the ratio of the Claims(annual growth as % of broad money) of Maldives in 2005 to that in 2011?
Ensure brevity in your answer.  5.78. What is the ratio of the Claims(annual growth as % of broad money) in Mauritius in 2005 to that in 2011?
Your answer should be compact. 0.87. What is the ratio of the Claims(annual growth as % of broad money) in Nigeria in 2005 to that in 2011?
Keep it short and to the point. 0.75. What is the ratio of the Claims(annual growth as % of broad money) in Belize in 2005 to that in 2012?
Your answer should be compact. 3.05. What is the ratio of the Claims(annual growth as % of broad money) of Mauritius in 2005 to that in 2012?
Give a very brief answer. 0.56. What is the ratio of the Claims(annual growth as % of broad money) in Nigeria in 2005 to that in 2012?
Your answer should be compact. 2.94. What is the ratio of the Claims(annual growth as % of broad money) in Belize in 2006 to that in 2007?
Provide a short and direct response. 0.75. What is the ratio of the Claims(annual growth as % of broad money) in Maldives in 2006 to that in 2007?
Ensure brevity in your answer.  0.73. What is the ratio of the Claims(annual growth as % of broad money) in Mauritius in 2006 to that in 2007?
Keep it short and to the point. 0.81. What is the ratio of the Claims(annual growth as % of broad money) in Nigeria in 2006 to that in 2007?
Your response must be concise. 0.27. What is the ratio of the Claims(annual growth as % of broad money) of Belize in 2006 to that in 2008?
Provide a short and direct response. 1.08. What is the ratio of the Claims(annual growth as % of broad money) of Maldives in 2006 to that in 2008?
Ensure brevity in your answer.  1. What is the ratio of the Claims(annual growth as % of broad money) of Mauritius in 2006 to that in 2008?
Keep it short and to the point. 0.44. What is the ratio of the Claims(annual growth as % of broad money) of Nigeria in 2006 to that in 2008?
Make the answer very short. 0.37. What is the ratio of the Claims(annual growth as % of broad money) in Belize in 2006 to that in 2009?
Provide a succinct answer. 3. What is the ratio of the Claims(annual growth as % of broad money) in Mauritius in 2006 to that in 2009?
Offer a very short reply. 12.15. What is the ratio of the Claims(annual growth as % of broad money) in Nigeria in 2006 to that in 2009?
Offer a terse response. 1.42. What is the ratio of the Claims(annual growth as % of broad money) in Mauritius in 2006 to that in 2010?
Keep it short and to the point. 0.98. What is the ratio of the Claims(annual growth as % of broad money) of Belize in 2006 to that in 2011?
Make the answer very short. 11.34. What is the ratio of the Claims(annual growth as % of broad money) of Maldives in 2006 to that in 2011?
Give a very brief answer. 6.29. What is the ratio of the Claims(annual growth as % of broad money) in Mauritius in 2006 to that in 2011?
Keep it short and to the point. 0.91. What is the ratio of the Claims(annual growth as % of broad money) of Nigeria in 2006 to that in 2011?
Ensure brevity in your answer.  0.83. What is the ratio of the Claims(annual growth as % of broad money) in Belize in 2006 to that in 2012?
Make the answer very short. 5. What is the ratio of the Claims(annual growth as % of broad money) in Mauritius in 2006 to that in 2012?
Your answer should be very brief. 0.58. What is the ratio of the Claims(annual growth as % of broad money) in Nigeria in 2006 to that in 2012?
Give a very brief answer. 3.22. What is the ratio of the Claims(annual growth as % of broad money) of Belize in 2007 to that in 2008?
Offer a terse response. 1.43. What is the ratio of the Claims(annual growth as % of broad money) in Maldives in 2007 to that in 2008?
Your answer should be very brief. 1.37. What is the ratio of the Claims(annual growth as % of broad money) of Mauritius in 2007 to that in 2008?
Offer a very short reply. 0.55. What is the ratio of the Claims(annual growth as % of broad money) of Nigeria in 2007 to that in 2008?
Provide a succinct answer. 1.38. What is the ratio of the Claims(annual growth as % of broad money) in Belize in 2007 to that in 2009?
Give a very brief answer. 3.97. What is the ratio of the Claims(annual growth as % of broad money) of Mauritius in 2007 to that in 2009?
Offer a terse response. 14.99. What is the ratio of the Claims(annual growth as % of broad money) of Nigeria in 2007 to that in 2009?
Keep it short and to the point. 5.22. What is the ratio of the Claims(annual growth as % of broad money) in Mauritius in 2007 to that in 2010?
Ensure brevity in your answer.  1.21. What is the ratio of the Claims(annual growth as % of broad money) in Belize in 2007 to that in 2011?
Give a very brief answer. 15.03. What is the ratio of the Claims(annual growth as % of broad money) in Maldives in 2007 to that in 2011?
Ensure brevity in your answer.  8.6. What is the ratio of the Claims(annual growth as % of broad money) in Mauritius in 2007 to that in 2011?
Offer a very short reply. 1.12. What is the ratio of the Claims(annual growth as % of broad money) of Nigeria in 2007 to that in 2011?
Provide a short and direct response. 3.04. What is the ratio of the Claims(annual growth as % of broad money) in Belize in 2007 to that in 2012?
Ensure brevity in your answer.  6.63. What is the ratio of the Claims(annual growth as % of broad money) in Mauritius in 2007 to that in 2012?
Your response must be concise. 0.72. What is the ratio of the Claims(annual growth as % of broad money) in Nigeria in 2007 to that in 2012?
Offer a terse response. 11.87. What is the ratio of the Claims(annual growth as % of broad money) of Belize in 2008 to that in 2009?
Your answer should be compact. 2.79. What is the ratio of the Claims(annual growth as % of broad money) in Mauritius in 2008 to that in 2009?
Provide a short and direct response. 27.45. What is the ratio of the Claims(annual growth as % of broad money) of Nigeria in 2008 to that in 2009?
Provide a succinct answer. 3.78. What is the ratio of the Claims(annual growth as % of broad money) in Mauritius in 2008 to that in 2010?
Make the answer very short. 2.22. What is the ratio of the Claims(annual growth as % of broad money) in Belize in 2008 to that in 2011?
Offer a terse response. 10.54. What is the ratio of the Claims(annual growth as % of broad money) of Maldives in 2008 to that in 2011?
Ensure brevity in your answer.  6.29. What is the ratio of the Claims(annual growth as % of broad money) of Mauritius in 2008 to that in 2011?
Make the answer very short. 2.05. What is the ratio of the Claims(annual growth as % of broad money) in Nigeria in 2008 to that in 2011?
Give a very brief answer. 2.2. What is the ratio of the Claims(annual growth as % of broad money) of Belize in 2008 to that in 2012?
Provide a succinct answer. 4.65. What is the ratio of the Claims(annual growth as % of broad money) of Mauritius in 2008 to that in 2012?
Your answer should be very brief. 1.32. What is the ratio of the Claims(annual growth as % of broad money) of Nigeria in 2008 to that in 2012?
Keep it short and to the point. 8.59. What is the ratio of the Claims(annual growth as % of broad money) in Mauritius in 2009 to that in 2010?
Ensure brevity in your answer.  0.08. What is the ratio of the Claims(annual growth as % of broad money) in Belize in 2009 to that in 2011?
Your answer should be compact. 3.78. What is the ratio of the Claims(annual growth as % of broad money) in Mauritius in 2009 to that in 2011?
Your answer should be very brief. 0.07. What is the ratio of the Claims(annual growth as % of broad money) of Nigeria in 2009 to that in 2011?
Your answer should be very brief. 0.58. What is the ratio of the Claims(annual growth as % of broad money) of Belize in 2009 to that in 2012?
Your answer should be compact. 1.67. What is the ratio of the Claims(annual growth as % of broad money) in Mauritius in 2009 to that in 2012?
Offer a terse response. 0.05. What is the ratio of the Claims(annual growth as % of broad money) of Nigeria in 2009 to that in 2012?
Your answer should be very brief. 2.28. What is the ratio of the Claims(annual growth as % of broad money) of Mauritius in 2010 to that in 2011?
Your answer should be very brief. 0.92. What is the ratio of the Claims(annual growth as % of broad money) of Mauritius in 2010 to that in 2012?
Ensure brevity in your answer.  0.59. What is the ratio of the Claims(annual growth as % of broad money) in Belize in 2011 to that in 2012?
Keep it short and to the point. 0.44. What is the ratio of the Claims(annual growth as % of broad money) in Mauritius in 2011 to that in 2012?
Give a very brief answer. 0.64. What is the ratio of the Claims(annual growth as % of broad money) of Nigeria in 2011 to that in 2012?
Offer a very short reply. 3.9. What is the difference between the highest and the second highest Claims(annual growth as % of broad money) in Belize?
Your answer should be very brief. 3.24. What is the difference between the highest and the second highest Claims(annual growth as % of broad money) of Maldives?
Make the answer very short. 15.32. What is the difference between the highest and the second highest Claims(annual growth as % of broad money) of Mauritius?
Make the answer very short. 5.29. What is the difference between the highest and the second highest Claims(annual growth as % of broad money) in Nigeria?
Your answer should be very brief. 24.38. What is the difference between the highest and the lowest Claims(annual growth as % of broad money) in Belize?
Your response must be concise. 13.2. What is the difference between the highest and the lowest Claims(annual growth as % of broad money) in Maldives?
Give a very brief answer. 57.21. What is the difference between the highest and the lowest Claims(annual growth as % of broad money) in Mauritius?
Your answer should be very brief. 21.12. What is the difference between the highest and the lowest Claims(annual growth as % of broad money) in Nigeria?
Give a very brief answer. 88.3. 